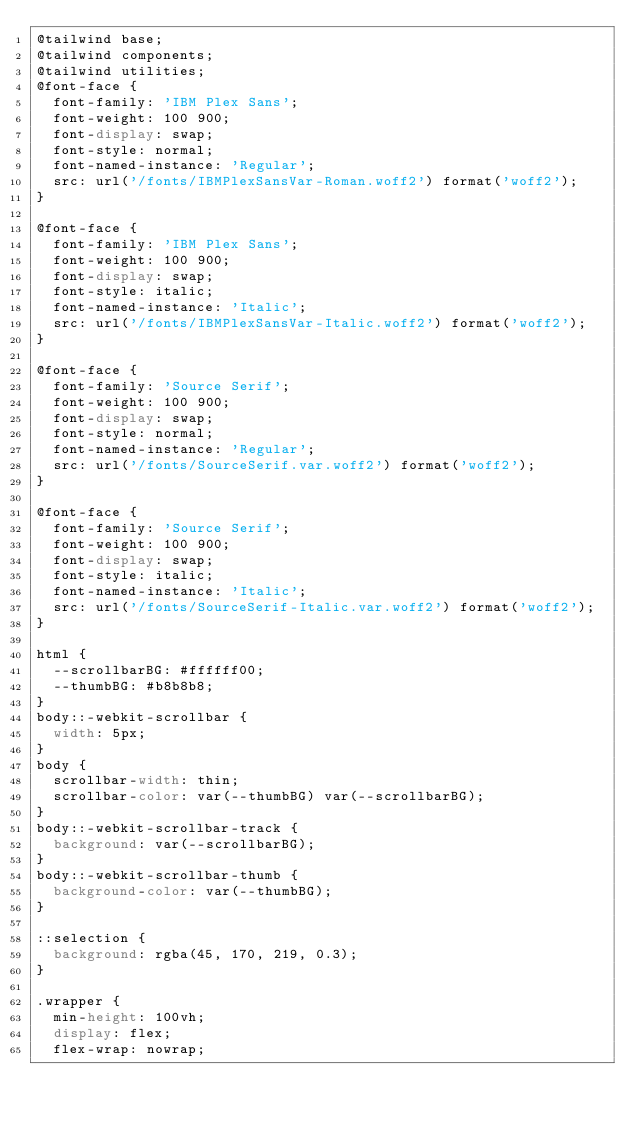<code> <loc_0><loc_0><loc_500><loc_500><_CSS_>@tailwind base;
@tailwind components;
@tailwind utilities;
@font-face {
  font-family: 'IBM Plex Sans';
  font-weight: 100 900;
  font-display: swap;
  font-style: normal;
  font-named-instance: 'Regular';
  src: url('/fonts/IBMPlexSansVar-Roman.woff2') format('woff2');
}

@font-face {
  font-family: 'IBM Plex Sans';
  font-weight: 100 900;
  font-display: swap;
  font-style: italic;
  font-named-instance: 'Italic';
  src: url('/fonts/IBMPlexSansVar-Italic.woff2') format('woff2');
}

@font-face {
  font-family: 'Source Serif';
  font-weight: 100 900;
  font-display: swap;
  font-style: normal;
  font-named-instance: 'Regular';
  src: url('/fonts/SourceSerif.var.woff2') format('woff2');
}

@font-face {
  font-family: 'Source Serif';
  font-weight: 100 900;
  font-display: swap;
  font-style: italic;
  font-named-instance: 'Italic';
  src: url('/fonts/SourceSerif-Italic.var.woff2') format('woff2');
}

html {
  --scrollbarBG: #ffffff00;
  --thumbBG: #b8b8b8;
}
body::-webkit-scrollbar {
  width: 5px;
}
body {
  scrollbar-width: thin;
  scrollbar-color: var(--thumbBG) var(--scrollbarBG);
}
body::-webkit-scrollbar-track {
  background: var(--scrollbarBG);
}
body::-webkit-scrollbar-thumb {
  background-color: var(--thumbBG);
}

::selection {
  background: rgba(45, 170, 219, 0.3);
}

.wrapper {
  min-height: 100vh;
  display: flex;
  flex-wrap: nowrap;</code> 